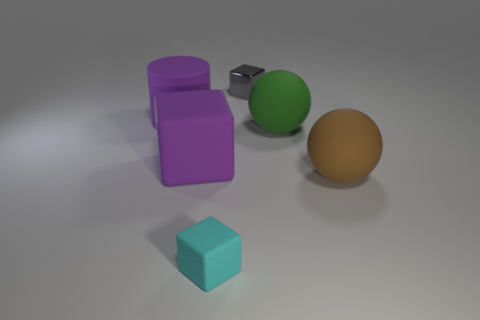There is a matte thing that is the same color as the big cylinder; what is its size?
Offer a very short reply. Large. Is the number of cubes behind the green object less than the number of large rubber things that are in front of the big purple rubber cylinder?
Make the answer very short. Yes. There is a block that is left of the cyan block; is it the same size as the tiny gray block?
Provide a short and direct response. No. What is the shape of the small thing in front of the small gray metal thing?
Make the answer very short. Cube. Are there more big brown matte things than tiny objects?
Provide a short and direct response. No. There is a matte object behind the green sphere; does it have the same color as the large block?
Give a very brief answer. Yes. How many objects are matte objects in front of the large purple rubber cylinder or big purple rubber things on the left side of the small gray metal object?
Give a very brief answer. 5. What number of objects are both on the right side of the cyan rubber block and behind the big green rubber object?
Offer a very short reply. 1. Does the big purple block have the same material as the tiny gray block?
Your answer should be very brief. No. The tiny thing in front of the big purple thing behind the purple matte object in front of the purple rubber cylinder is what shape?
Provide a succinct answer. Cube. 